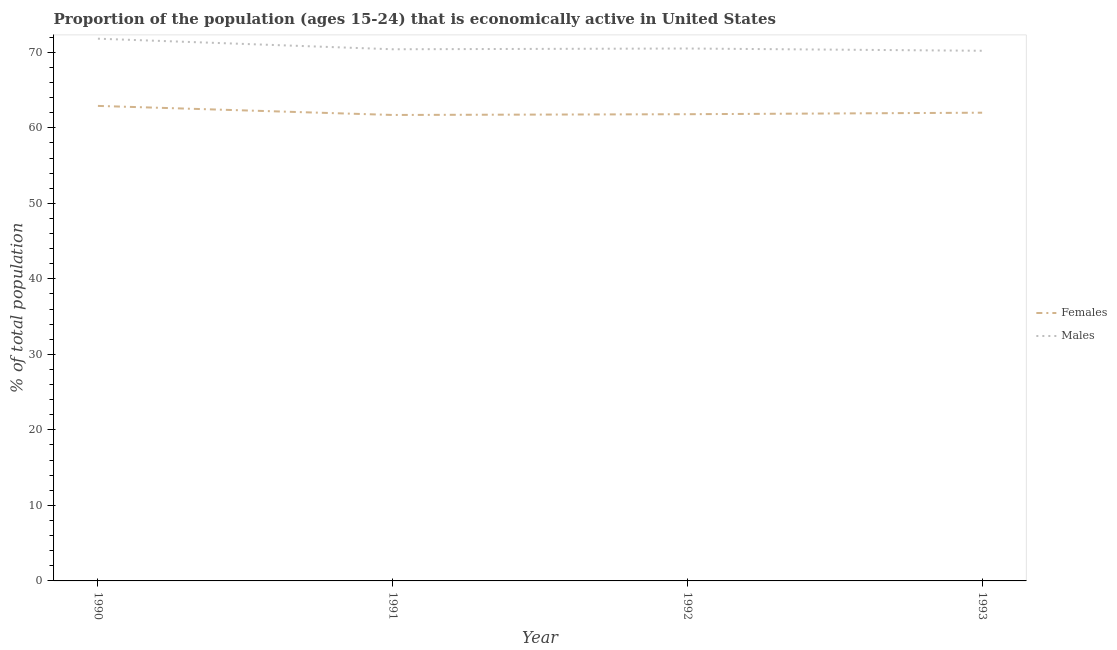How many different coloured lines are there?
Give a very brief answer. 2. Is the number of lines equal to the number of legend labels?
Your answer should be compact. Yes. What is the percentage of economically active female population in 1992?
Your answer should be compact. 61.8. Across all years, what is the maximum percentage of economically active female population?
Your answer should be compact. 62.9. Across all years, what is the minimum percentage of economically active female population?
Keep it short and to the point. 61.7. In which year was the percentage of economically active male population minimum?
Provide a succinct answer. 1993. What is the total percentage of economically active female population in the graph?
Offer a terse response. 248.4. What is the difference between the percentage of economically active female population in 1990 and that in 1991?
Offer a terse response. 1.2. What is the difference between the percentage of economically active female population in 1991 and the percentage of economically active male population in 1993?
Provide a short and direct response. -8.5. What is the average percentage of economically active male population per year?
Your answer should be compact. 70.73. In the year 1990, what is the difference between the percentage of economically active male population and percentage of economically active female population?
Make the answer very short. 8.9. What is the ratio of the percentage of economically active female population in 1990 to that in 1992?
Provide a succinct answer. 1.02. Is the percentage of economically active female population in 1990 less than that in 1992?
Keep it short and to the point. No. What is the difference between the highest and the second highest percentage of economically active male population?
Your answer should be compact. 1.3. What is the difference between the highest and the lowest percentage of economically active female population?
Provide a succinct answer. 1.2. Is the sum of the percentage of economically active male population in 1990 and 1993 greater than the maximum percentage of economically active female population across all years?
Offer a terse response. Yes. Does the percentage of economically active female population monotonically increase over the years?
Offer a very short reply. No. Is the percentage of economically active female population strictly less than the percentage of economically active male population over the years?
Give a very brief answer. Yes. How many years are there in the graph?
Offer a very short reply. 4. Where does the legend appear in the graph?
Offer a very short reply. Center right. How many legend labels are there?
Ensure brevity in your answer.  2. How are the legend labels stacked?
Ensure brevity in your answer.  Vertical. What is the title of the graph?
Your answer should be compact. Proportion of the population (ages 15-24) that is economically active in United States. Does "Chemicals" appear as one of the legend labels in the graph?
Give a very brief answer. No. What is the label or title of the Y-axis?
Offer a terse response. % of total population. What is the % of total population in Females in 1990?
Keep it short and to the point. 62.9. What is the % of total population in Males in 1990?
Offer a terse response. 71.8. What is the % of total population in Females in 1991?
Make the answer very short. 61.7. What is the % of total population of Males in 1991?
Provide a succinct answer. 70.4. What is the % of total population of Females in 1992?
Offer a terse response. 61.8. What is the % of total population of Males in 1992?
Give a very brief answer. 70.5. What is the % of total population in Females in 1993?
Provide a succinct answer. 62. What is the % of total population in Males in 1993?
Your answer should be compact. 70.2. Across all years, what is the maximum % of total population of Females?
Your answer should be very brief. 62.9. Across all years, what is the maximum % of total population in Males?
Offer a terse response. 71.8. Across all years, what is the minimum % of total population in Females?
Your answer should be very brief. 61.7. Across all years, what is the minimum % of total population of Males?
Your answer should be very brief. 70.2. What is the total % of total population of Females in the graph?
Make the answer very short. 248.4. What is the total % of total population in Males in the graph?
Make the answer very short. 282.9. What is the difference between the % of total population of Females in 1990 and that in 1991?
Provide a succinct answer. 1.2. What is the difference between the % of total population of Females in 1990 and that in 1992?
Provide a succinct answer. 1.1. What is the difference between the % of total population of Females in 1990 and that in 1993?
Make the answer very short. 0.9. What is the difference between the % of total population in Females in 1991 and that in 1992?
Offer a terse response. -0.1. What is the difference between the % of total population of Males in 1991 and that in 1992?
Make the answer very short. -0.1. What is the difference between the % of total population of Females in 1991 and that in 1993?
Your response must be concise. -0.3. What is the difference between the % of total population in Males in 1991 and that in 1993?
Your answer should be compact. 0.2. What is the difference between the % of total population of Females in 1990 and the % of total population of Males in 1993?
Offer a very short reply. -7.3. What is the average % of total population in Females per year?
Make the answer very short. 62.1. What is the average % of total population in Males per year?
Your answer should be very brief. 70.72. In the year 1990, what is the difference between the % of total population in Females and % of total population in Males?
Provide a succinct answer. -8.9. In the year 1993, what is the difference between the % of total population in Females and % of total population in Males?
Offer a terse response. -8.2. What is the ratio of the % of total population of Females in 1990 to that in 1991?
Keep it short and to the point. 1.02. What is the ratio of the % of total population in Males in 1990 to that in 1991?
Offer a terse response. 1.02. What is the ratio of the % of total population of Females in 1990 to that in 1992?
Provide a succinct answer. 1.02. What is the ratio of the % of total population in Males in 1990 to that in 1992?
Keep it short and to the point. 1.02. What is the ratio of the % of total population of Females in 1990 to that in 1993?
Your answer should be very brief. 1.01. What is the ratio of the % of total population in Males in 1990 to that in 1993?
Your response must be concise. 1.02. What is the ratio of the % of total population of Females in 1991 to that in 1992?
Keep it short and to the point. 1. What is the ratio of the % of total population of Females in 1992 to that in 1993?
Provide a short and direct response. 1. What is the ratio of the % of total population in Males in 1992 to that in 1993?
Your response must be concise. 1. What is the difference between the highest and the second highest % of total population of Males?
Make the answer very short. 1.3. 